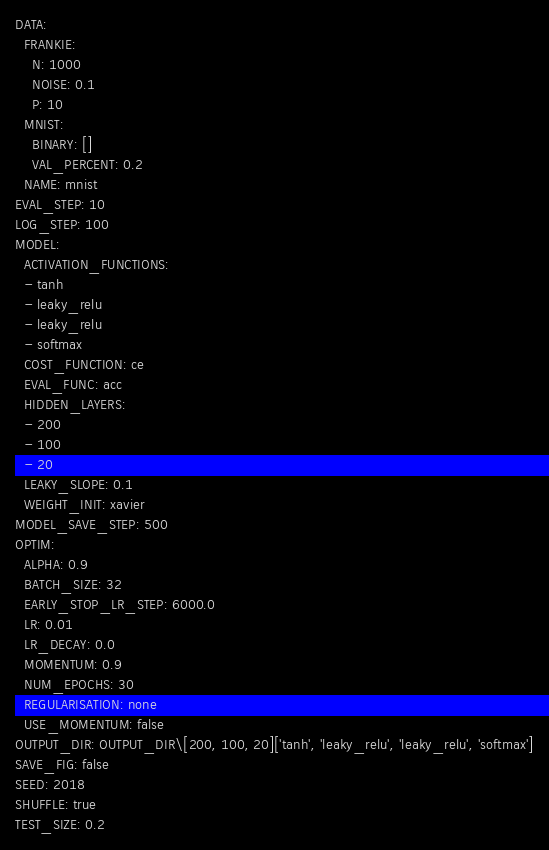<code> <loc_0><loc_0><loc_500><loc_500><_YAML_>DATA:
  FRANKIE:
    N: 1000
    NOISE: 0.1
    P: 10
  MNIST:
    BINARY: []
    VAL_PERCENT: 0.2
  NAME: mnist
EVAL_STEP: 10
LOG_STEP: 100
MODEL:
  ACTIVATION_FUNCTIONS:
  - tanh
  - leaky_relu
  - leaky_relu
  - softmax
  COST_FUNCTION: ce
  EVAL_FUNC: acc
  HIDDEN_LAYERS:
  - 200
  - 100
  - 20
  LEAKY_SLOPE: 0.1
  WEIGHT_INIT: xavier
MODEL_SAVE_STEP: 500
OPTIM:
  ALPHA: 0.9
  BATCH_SIZE: 32
  EARLY_STOP_LR_STEP: 6000.0
  LR: 0.01
  LR_DECAY: 0.0
  MOMENTUM: 0.9
  NUM_EPOCHS: 30
  REGULARISATION: none
  USE_MOMENTUM: false
OUTPUT_DIR: OUTPUT_DIR\[200, 100, 20]['tanh', 'leaky_relu', 'leaky_relu', 'softmax']
SAVE_FIG: false
SEED: 2018
SHUFFLE: true
TEST_SIZE: 0.2
</code> 